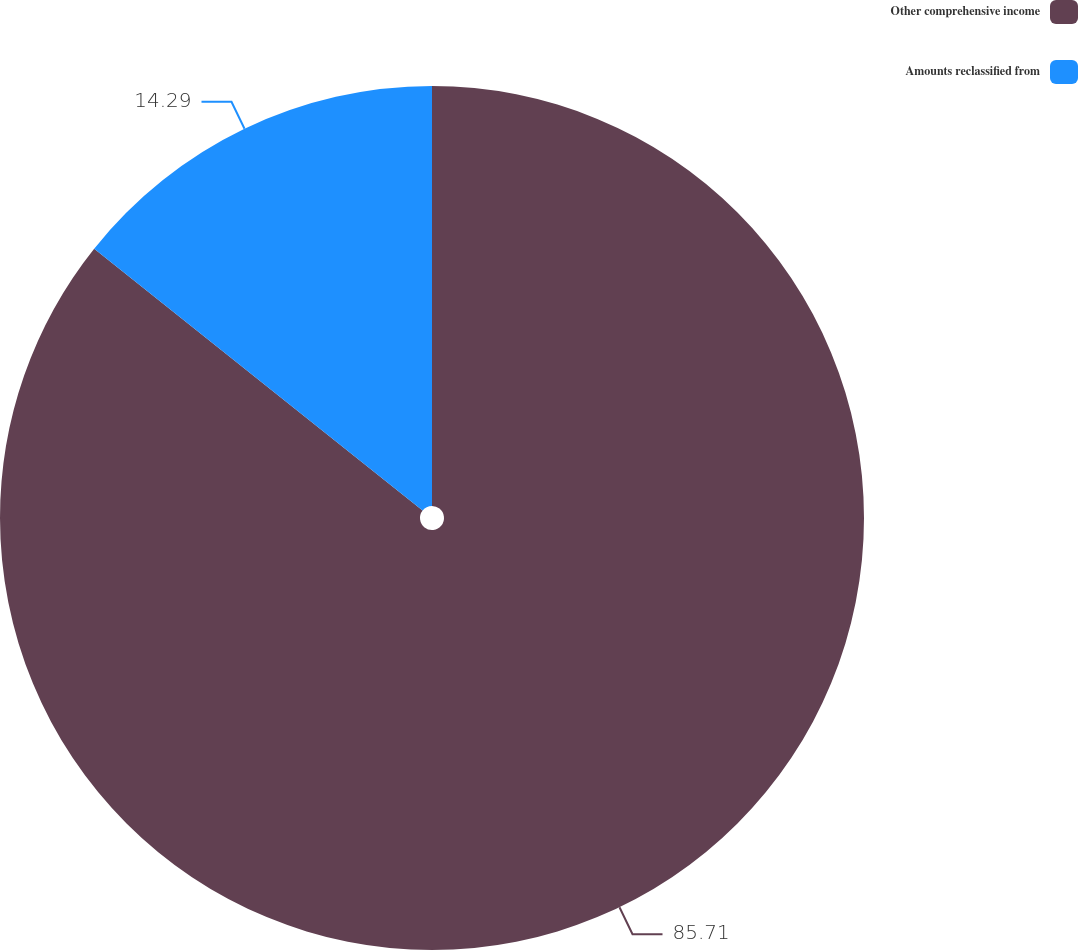<chart> <loc_0><loc_0><loc_500><loc_500><pie_chart><fcel>Other comprehensive income<fcel>Amounts reclassified from<nl><fcel>85.71%<fcel>14.29%<nl></chart> 